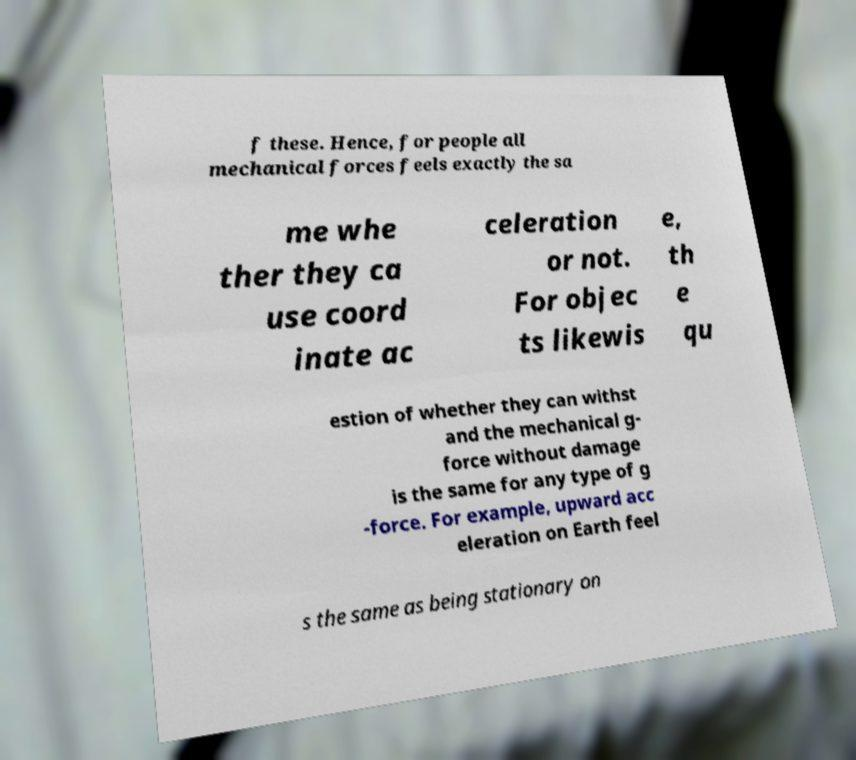There's text embedded in this image that I need extracted. Can you transcribe it verbatim? f these. Hence, for people all mechanical forces feels exactly the sa me whe ther they ca use coord inate ac celeration or not. For objec ts likewis e, th e qu estion of whether they can withst and the mechanical g- force without damage is the same for any type of g -force. For example, upward acc eleration on Earth feel s the same as being stationary on 